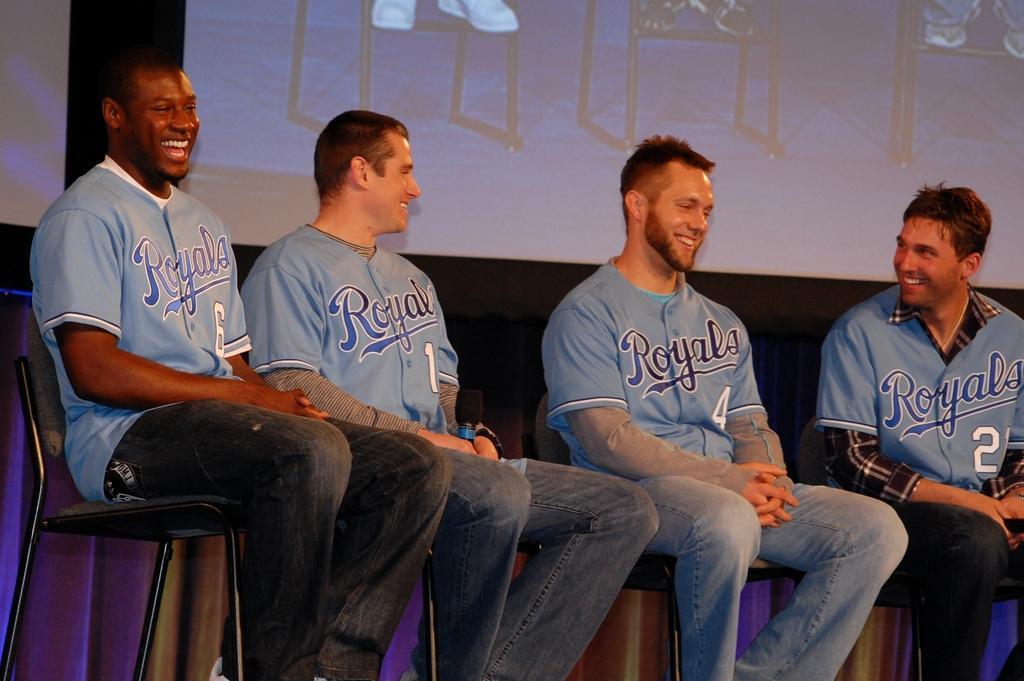In one or two sentences, can you explain what this image depicts? In this picture we can see four men, they are sitting on the chairs and they are all smiling, behind them we can see a projector screen. 